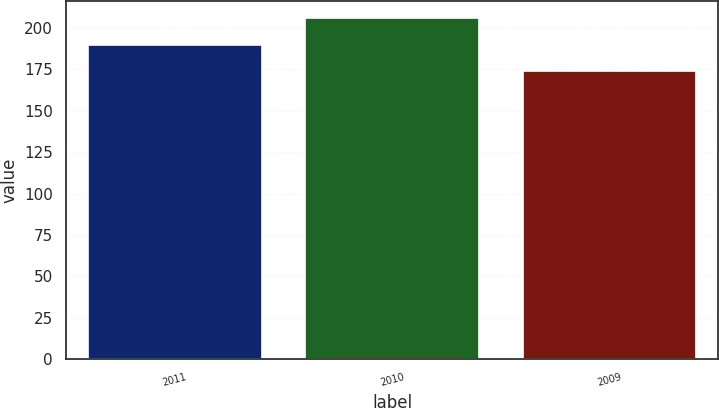Convert chart to OTSL. <chart><loc_0><loc_0><loc_500><loc_500><bar_chart><fcel>2011<fcel>2010<fcel>2009<nl><fcel>190<fcel>206<fcel>174<nl></chart> 